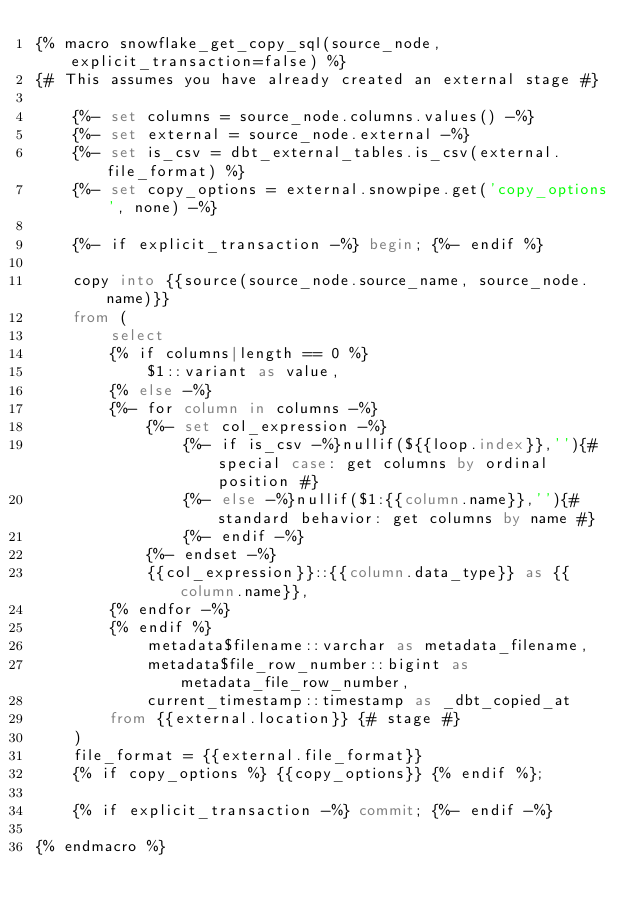<code> <loc_0><loc_0><loc_500><loc_500><_SQL_>{% macro snowflake_get_copy_sql(source_node, explicit_transaction=false) %}
{# This assumes you have already created an external stage #}

    {%- set columns = source_node.columns.values() -%}
    {%- set external = source_node.external -%}
    {%- set is_csv = dbt_external_tables.is_csv(external.file_format) %}
    {%- set copy_options = external.snowpipe.get('copy_options', none) -%}
    
    {%- if explicit_transaction -%} begin; {%- endif %}
    
    copy into {{source(source_node.source_name, source_node.name)}}
    from ( 
        select
        {% if columns|length == 0 %}
            $1::variant as value,
        {% else -%}
        {%- for column in columns -%}
            {%- set col_expression -%}
                {%- if is_csv -%}nullif(${{loop.index}},''){# special case: get columns by ordinal position #}
                {%- else -%}nullif($1:{{column.name}},''){# standard behavior: get columns by name #}
                {%- endif -%}
            {%- endset -%}
            {{col_expression}}::{{column.data_type}} as {{column.name}},
        {% endfor -%}
        {% endif %}
            metadata$filename::varchar as metadata_filename,
            metadata$file_row_number::bigint as metadata_file_row_number,
            current_timestamp::timestamp as _dbt_copied_at
        from {{external.location}} {# stage #}
    )
    file_format = {{external.file_format}}
    {% if copy_options %} {{copy_options}} {% endif %};
    
    {% if explicit_transaction -%} commit; {%- endif -%}

{% endmacro %}
</code> 